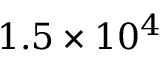<formula> <loc_0><loc_0><loc_500><loc_500>1 . 5 \times 1 0 ^ { 4 }</formula> 